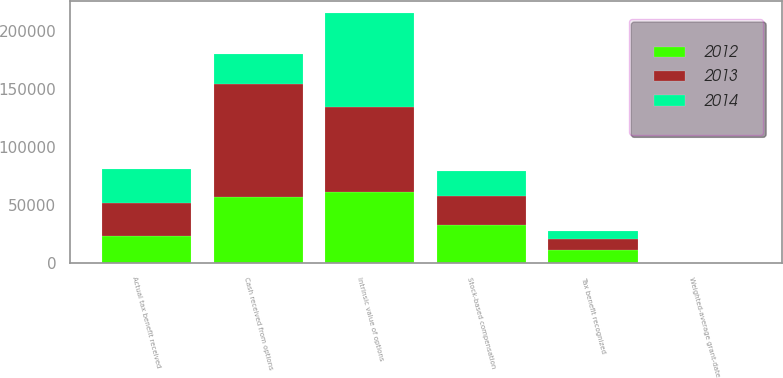<chart> <loc_0><loc_0><loc_500><loc_500><stacked_bar_chart><ecel><fcel>Stock-based compensation<fcel>Tax benefit recognized<fcel>Weighted-average grant-date<fcel>Intrinsic value of options<fcel>Cash received from options<fcel>Actual tax benefit received<nl><fcel>2012<fcel>32203<fcel>11271<fcel>14.77<fcel>61229<fcel>56294<fcel>23232<nl><fcel>2013<fcel>25642<fcel>8975<fcel>12.37<fcel>72793<fcel>97815<fcel>27972<nl><fcel>2014<fcel>21605<fcel>7562<fcel>10.47<fcel>80781<fcel>25642<fcel>29307<nl></chart> 